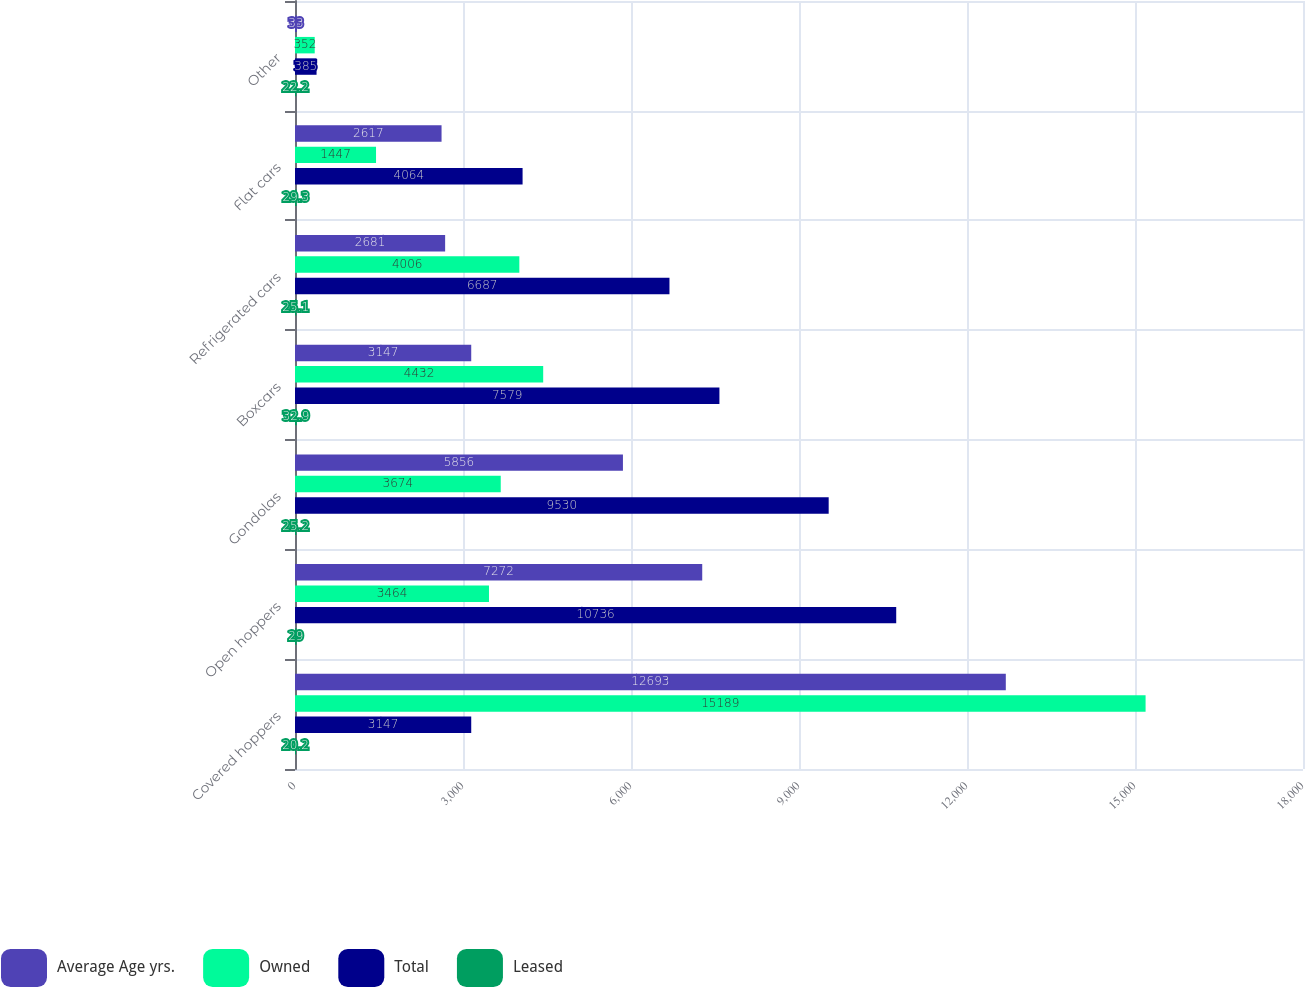Convert chart to OTSL. <chart><loc_0><loc_0><loc_500><loc_500><stacked_bar_chart><ecel><fcel>Covered hoppers<fcel>Open hoppers<fcel>Gondolas<fcel>Boxcars<fcel>Refrigerated cars<fcel>Flat cars<fcel>Other<nl><fcel>Average Age yrs.<fcel>12693<fcel>7272<fcel>5856<fcel>3147<fcel>2681<fcel>2617<fcel>33<nl><fcel>Owned<fcel>15189<fcel>3464<fcel>3674<fcel>4432<fcel>4006<fcel>1447<fcel>352<nl><fcel>Total<fcel>3147<fcel>10736<fcel>9530<fcel>7579<fcel>6687<fcel>4064<fcel>385<nl><fcel>Leased<fcel>20.2<fcel>29<fcel>25.2<fcel>32.9<fcel>25.1<fcel>29.3<fcel>22.2<nl></chart> 